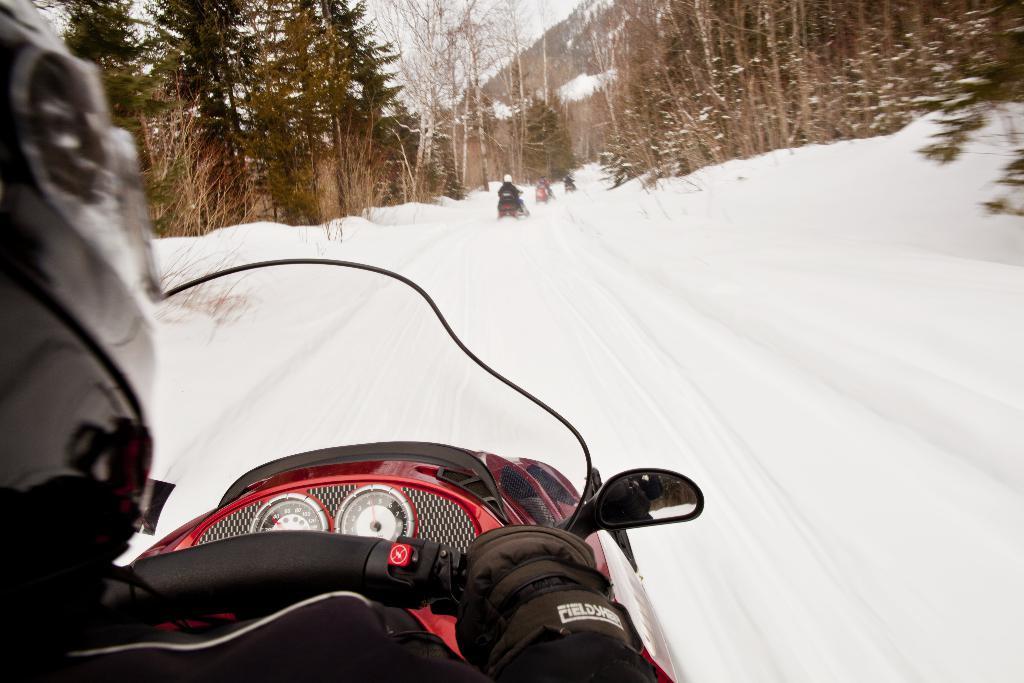Can you describe this image briefly? In this picture I can see few snow bikes and I can see trees and they wore helmets on their heads. 